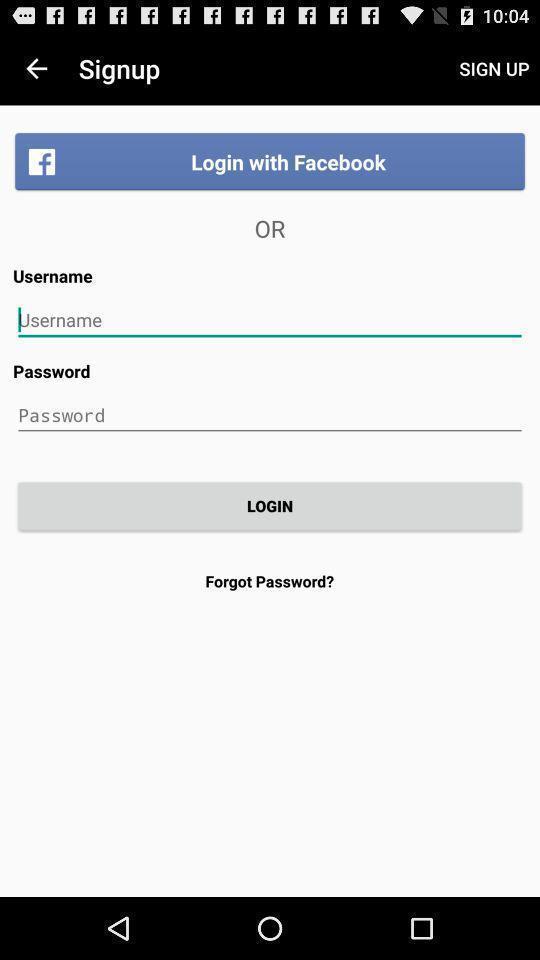Explain the elements present in this screenshot. Page displaying to enter details. 